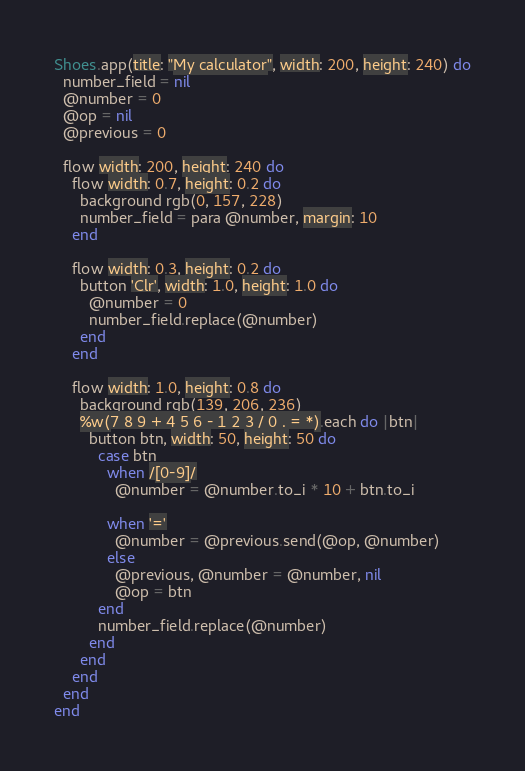<code> <loc_0><loc_0><loc_500><loc_500><_Ruby_>
Shoes.app(title: "My calculator", width: 200, height: 240) do
  number_field = nil
  @number = 0
  @op = nil
  @previous = 0

  flow width: 200, height: 240 do
    flow width: 0.7, height: 0.2 do
      background rgb(0, 157, 228)
      number_field = para @number, margin: 10
    end

    flow width: 0.3, height: 0.2 do
      button 'Clr', width: 1.0, height: 1.0 do
        @number = 0
        number_field.replace(@number)
      end
    end

    flow width: 1.0, height: 0.8 do
      background rgb(139, 206, 236)
      %w(7 8 9 + 4 5 6 - 1 2 3 / 0 . = *).each do |btn|
        button btn, width: 50, height: 50 do
          case btn
            when /[0-9]/
              @number = @number.to_i * 10 + btn.to_i

            when '='
              @number = @previous.send(@op, @number)
            else
              @previous, @number = @number, nil
              @op = btn
          end
          number_field.replace(@number)
        end
      end
    end
  end
end
</code> 